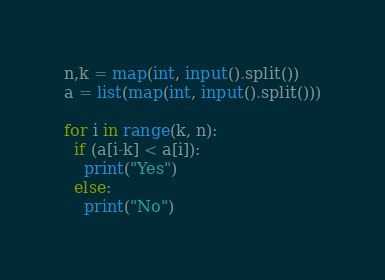<code> <loc_0><loc_0><loc_500><loc_500><_Python_>n,k = map(int, input().split())
a = list(map(int, input().split()))

for i in range(k, n):
  if (a[i-k] < a[i]):
    print("Yes")
  else:
    print("No")</code> 